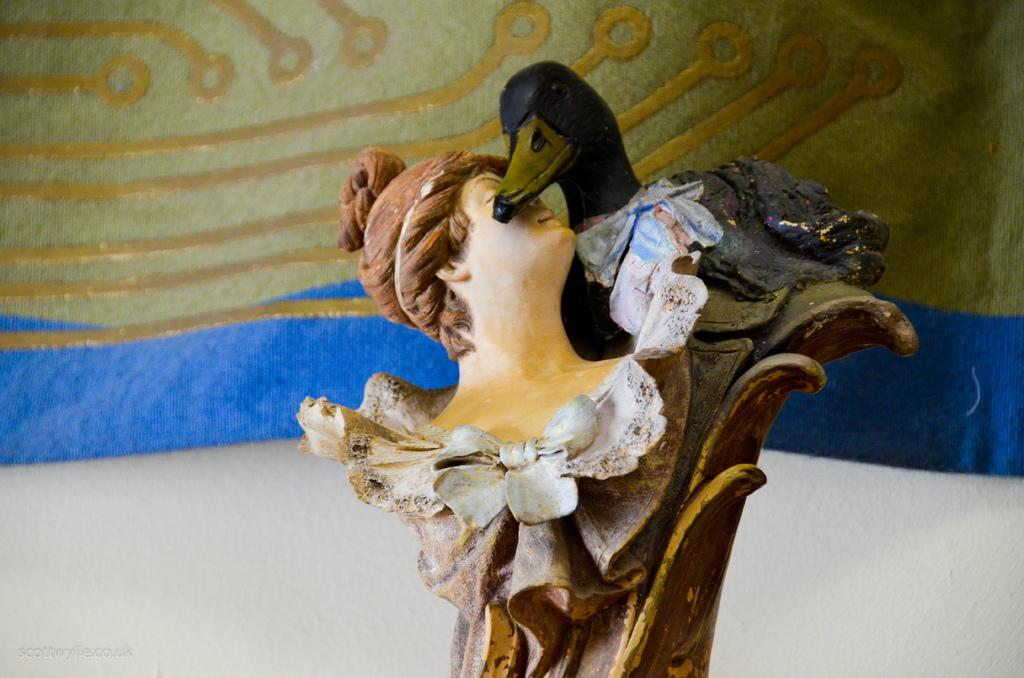What is the main subject in the image? There is a sculpture in the image. What else can be seen in the background of the image? There is a cloth and a wall in the background of the image. Where is the goat sitting in the image? There is no goat present in the image. What type of group is gathered around the sculpture in the image? There is no group of people gathered around the sculpture in the image. 